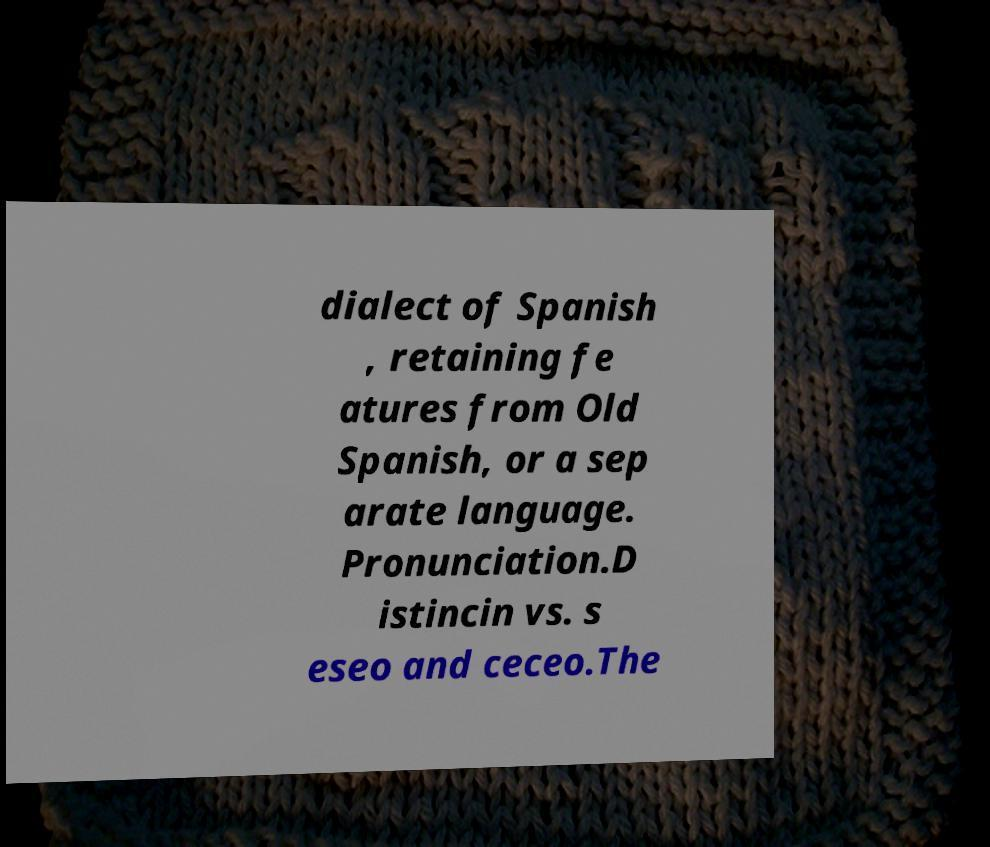Please read and relay the text visible in this image. What does it say? dialect of Spanish , retaining fe atures from Old Spanish, or a sep arate language. Pronunciation.D istincin vs. s eseo and ceceo.The 